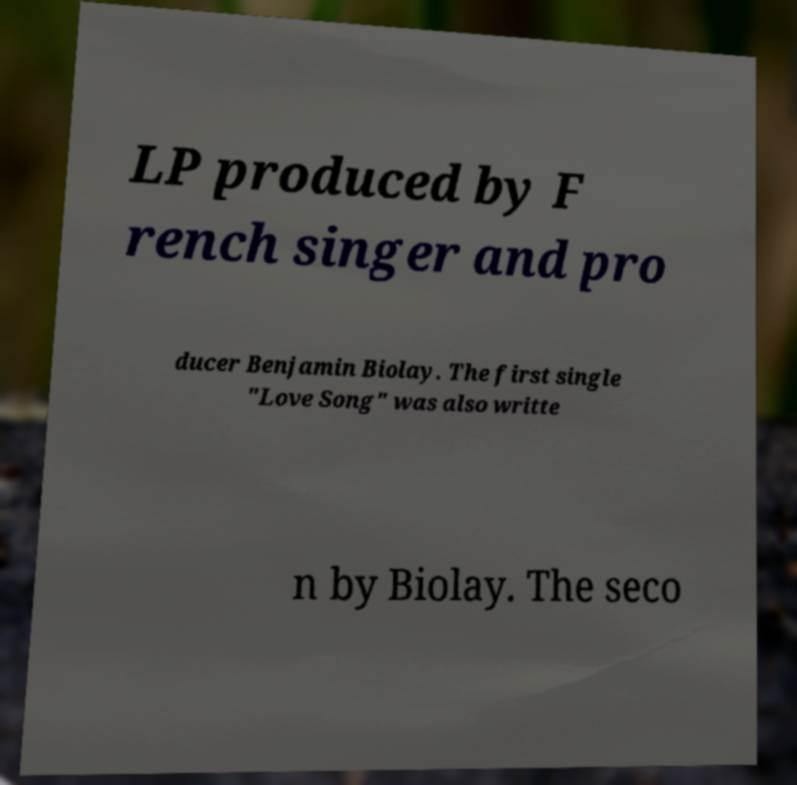For documentation purposes, I need the text within this image transcribed. Could you provide that? LP produced by F rench singer and pro ducer Benjamin Biolay. The first single "Love Song" was also writte n by Biolay. The seco 